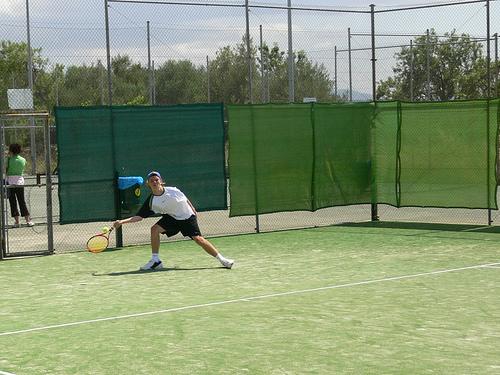Is this a professional tennis match?
Short answer required. No. What sport is being played?
Answer briefly. Tennis. What color is the line across the ground?
Write a very short answer. White. What kind of surface is this tennis court?
Be succinct. Grass. 